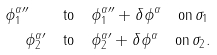<formula> <loc_0><loc_0><loc_500><loc_500>\phi ^ { \alpha \prime \prime } _ { 1 } \quad & \text {to} \quad \phi ^ { \alpha \prime \prime } _ { 1 } + \delta \phi ^ { \alpha } \quad \text {on} \, \sigma _ { 1 } \\ \phi ^ { \alpha \prime } _ { 2 } \quad & \text {to} \quad \phi ^ { \alpha \prime } _ { 2 } + \delta \phi ^ { \alpha } \quad \text {on} \, \sigma _ { 2 } .</formula> 